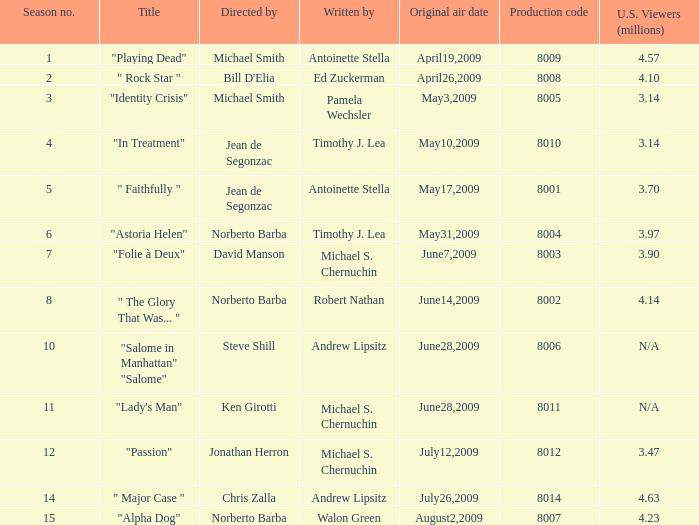Who are the writers when the production code is 8011? Michael S. Chernuchin. 